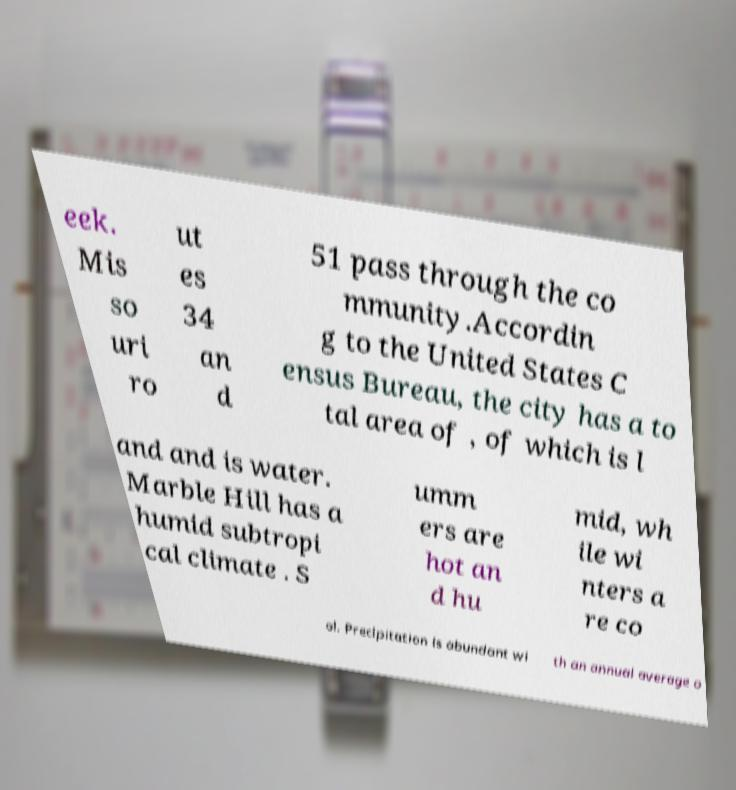For documentation purposes, I need the text within this image transcribed. Could you provide that? eek. Mis so uri ro ut es 34 an d 51 pass through the co mmunity.Accordin g to the United States C ensus Bureau, the city has a to tal area of , of which is l and and is water. Marble Hill has a humid subtropi cal climate . S umm ers are hot an d hu mid, wh ile wi nters a re co ol. Precipitation is abundant wi th an annual average o 